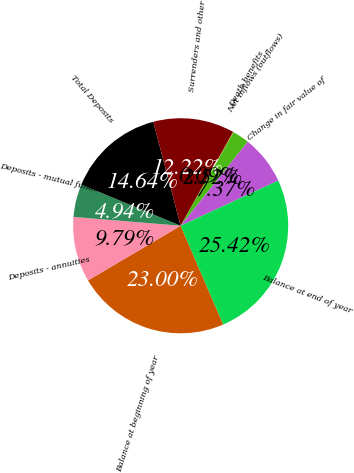Convert chart. <chart><loc_0><loc_0><loc_500><loc_500><pie_chart><fcel>Balance at beginning of year<fcel>Deposits - annuities<fcel>Deposits - mutual funds<fcel>Total Deposits<fcel>Surrenders and other<fcel>Death benefits<fcel>Net inflows (outflows)<fcel>Change in fair value of<fcel>Balance at end of year<nl><fcel>23.0%<fcel>9.79%<fcel>4.94%<fcel>14.64%<fcel>12.22%<fcel>0.09%<fcel>2.52%<fcel>7.37%<fcel>25.42%<nl></chart> 